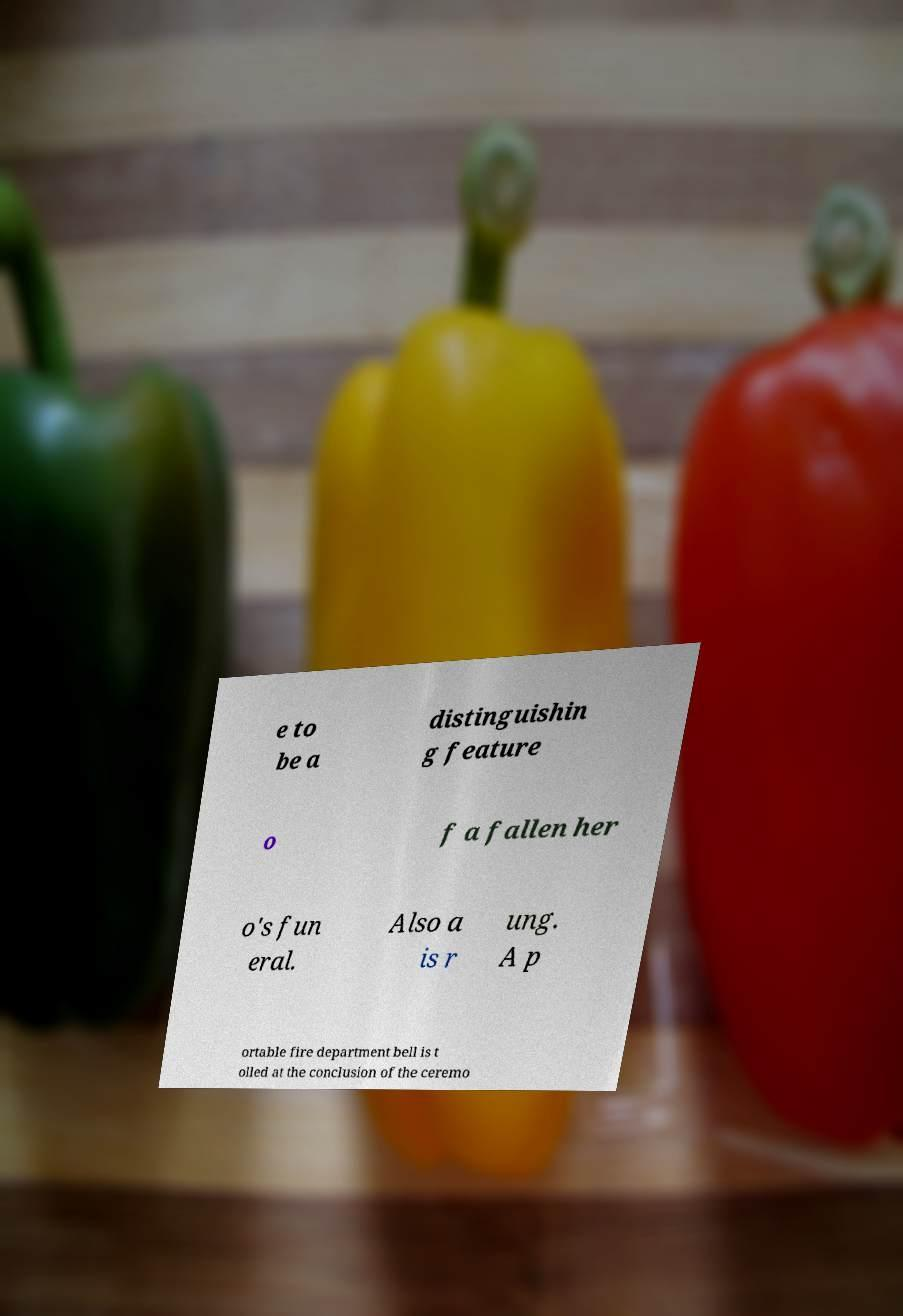I need the written content from this picture converted into text. Can you do that? e to be a distinguishin g feature o f a fallen her o's fun eral. Also a is r ung. A p ortable fire department bell is t olled at the conclusion of the ceremo 